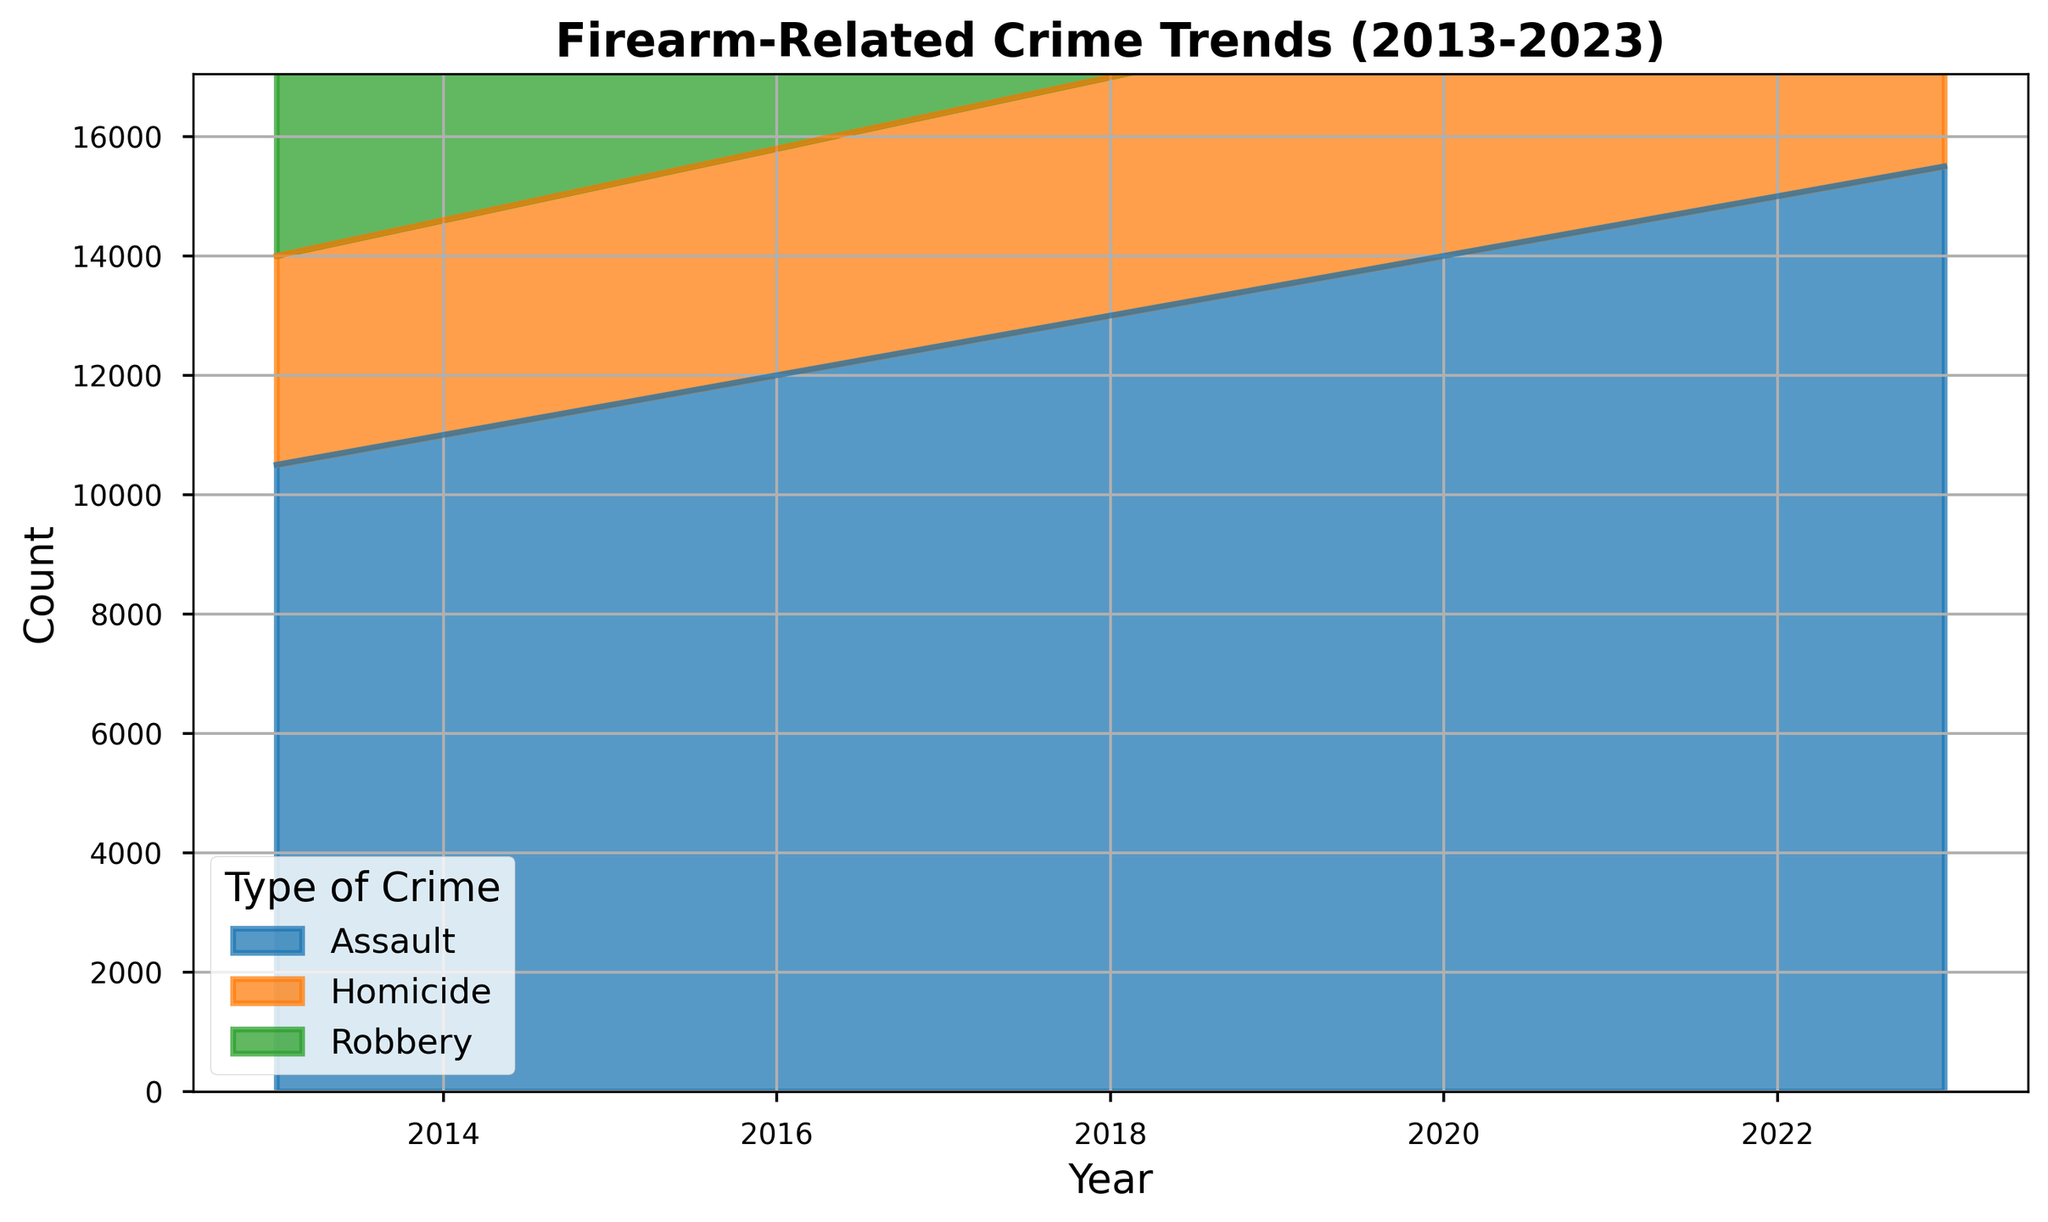what is the total count of firearm-related crimes in 2017? To find the total count of firearm-related crimes in 2017, sum the counts of each type of crime for that year: 12,500 (Assault) + 7,900 (Robbery) + 3,900 (Homicide) = 24,300.
Answer: 24,300 Which type of crime had the highest increase in count between 2013 and 2023? To determine which crime type had the highest increase, subtract the 2013 count from the 2023 count for each type: Assault (15,500 - 10,500 = 5,000), Robbery (8,500 - 7,500 = 1,000), Homicide (4,500 - 3,500 = 1,000). The highest increase is in Assault.
Answer: Assault In which year did the total count of firearm-related crimes first exceed 25,000? Calculate the total count for each year until it exceeds 25,000. In 2021, the total count is 14,500 (Assault) + 8,300 (Robbery) + 4,300 (Homicide) = 27,100, which exceeds 25,000.
Answer: 2021 Which crime type had the smallest relative rate of increase from 2013 to 2023? Calculate the relative rate of increase for each type of crime: (Assault, (15,500 - 10,500) / 10,500 = 0.476), (Robbery, (8,500 - 7,500) / 7,500 = 0.133), (Homicide, (4,500 - 3,500) / 3,500 = 0.286). The smallest rate is for Robbery.
Answer: Robbery What was the average annual count of homicides over the decade? To find the average, sum the homicide counts from 2013 to 2023 and divide by the number of years: (3,500 + 3,600 + 3,700 + 3,800 + 3,900 + 4,000 + 4,100 + 4,200 + 4,300 + 4,400 + 4,500) / 11 = 3,936.
Answer: 3,936 Is there any year where the count of assaults and robberies combined exceed 20,000? Check for each year if the sum of assault and robbery counts is greater than 20,000. From 2022 onwards, the sum exceeds 20,000 (15,000 + 8,400 = 23,400).
Answer: 2022 By how much did the count of assaults change from 2017 to 2021? Subtract the count in 2017 from the count in 2021: 14,500 (2021) - 12,500 (2017) = 2,000.
Answer: 2,000 Does any crime type show a year with a decreasing trend compared to the previous year? Review year-over-year changes for each crime type. None of the types (Assault, Robbery, Homicide) shows a decrease in any year; they all show consistent increases.
Answer: No 